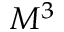Convert formula to latex. <formula><loc_0><loc_0><loc_500><loc_500>M ^ { 3 }</formula> 